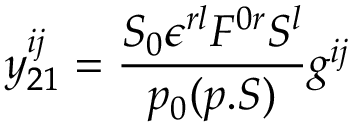<formula> <loc_0><loc_0><loc_500><loc_500>y _ { 2 1 } ^ { i j } = { \frac { S _ { 0 } \epsilon ^ { r l } F ^ { 0 r } S ^ { l } } { p _ { 0 } ( p . S ) } } g ^ { i j }</formula> 